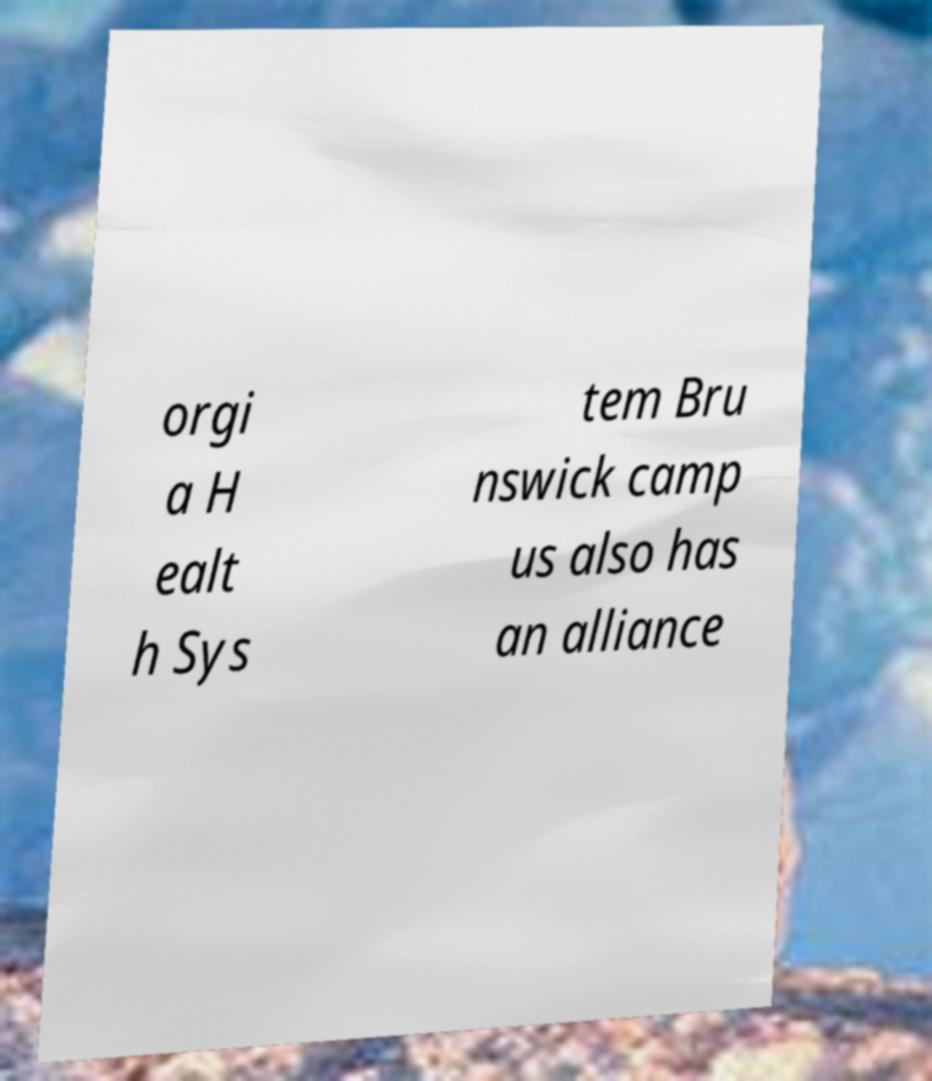I need the written content from this picture converted into text. Can you do that? orgi a H ealt h Sys tem Bru nswick camp us also has an alliance 